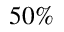Convert formula to latex. <formula><loc_0><loc_0><loc_500><loc_500>5 0 \%</formula> 